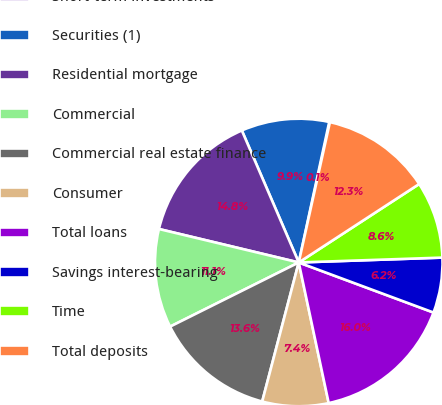Convert chart to OTSL. <chart><loc_0><loc_0><loc_500><loc_500><pie_chart><fcel>Short-term investments<fcel>Securities (1)<fcel>Residential mortgage<fcel>Commercial<fcel>Commercial real estate finance<fcel>Consumer<fcel>Total loans<fcel>Savings interest-bearing<fcel>Time<fcel>Total deposits<nl><fcel>0.08%<fcel>9.88%<fcel>14.78%<fcel>11.1%<fcel>13.55%<fcel>7.43%<fcel>16.0%<fcel>6.2%<fcel>8.65%<fcel>12.33%<nl></chart> 